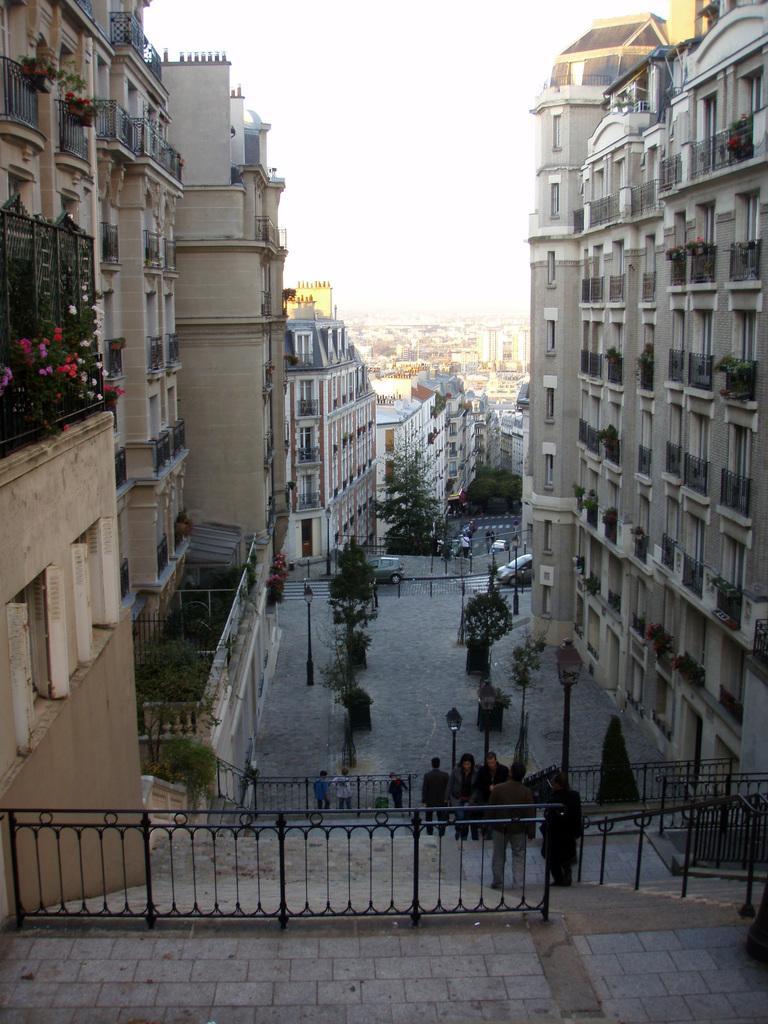Could you give a brief overview of what you see in this image? Here in this picture we can see buildings present all over there and we can see plants and trees present here and there and we can see light posts present and we can see railings present over there and we can see people walking over the steps in the front over there. 